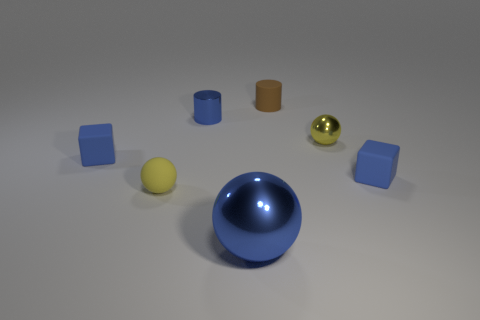Add 2 tiny brown rubber cylinders. How many objects exist? 9 Subtract all blocks. How many objects are left? 5 Subtract 0 green blocks. How many objects are left? 7 Subtract all large blue objects. Subtract all brown rubber things. How many objects are left? 5 Add 4 yellow metallic spheres. How many yellow metallic spheres are left? 5 Add 4 large blue metallic objects. How many large blue metallic objects exist? 5 